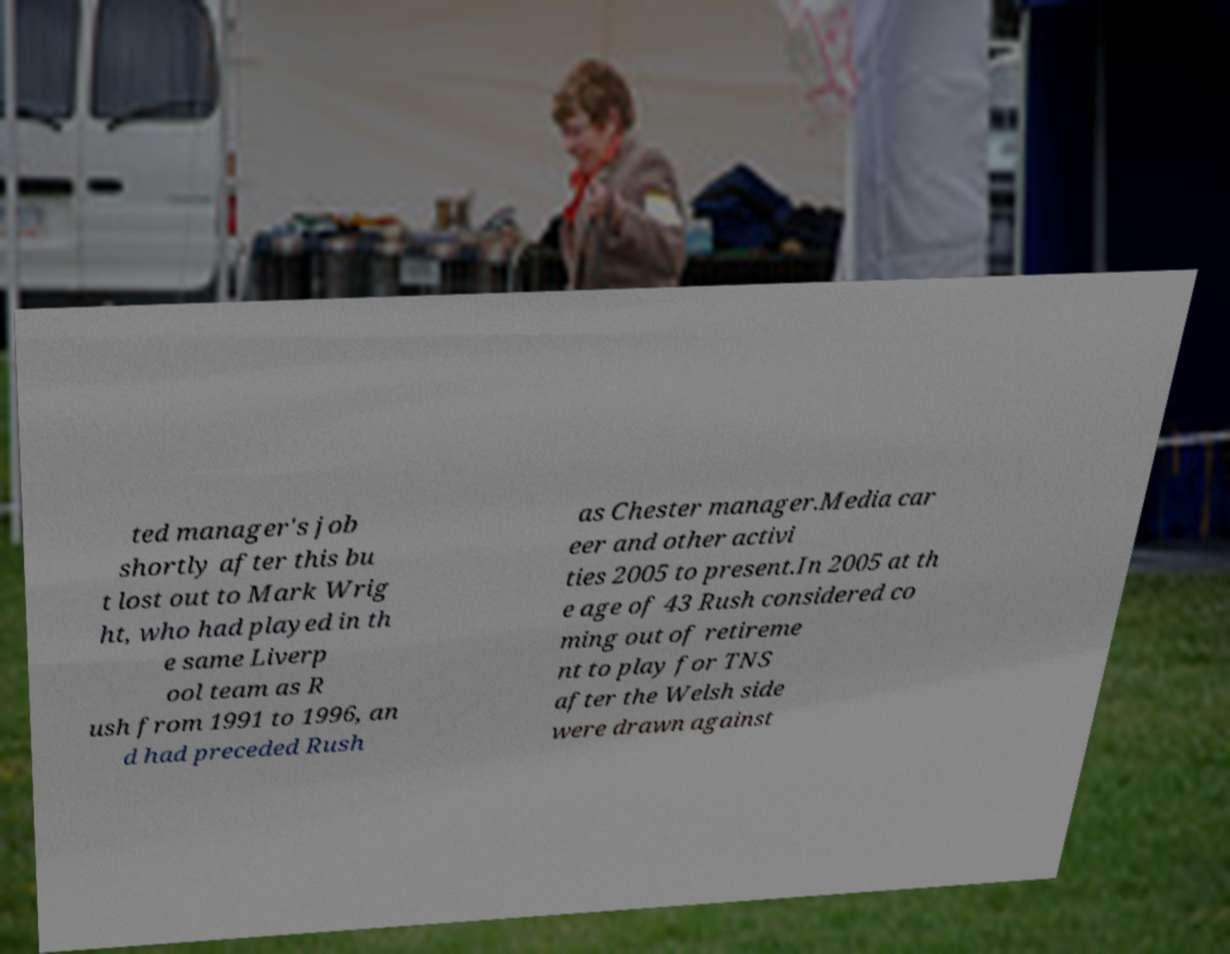Please read and relay the text visible in this image. What does it say? ted manager's job shortly after this bu t lost out to Mark Wrig ht, who had played in th e same Liverp ool team as R ush from 1991 to 1996, an d had preceded Rush as Chester manager.Media car eer and other activi ties 2005 to present.In 2005 at th e age of 43 Rush considered co ming out of retireme nt to play for TNS after the Welsh side were drawn against 